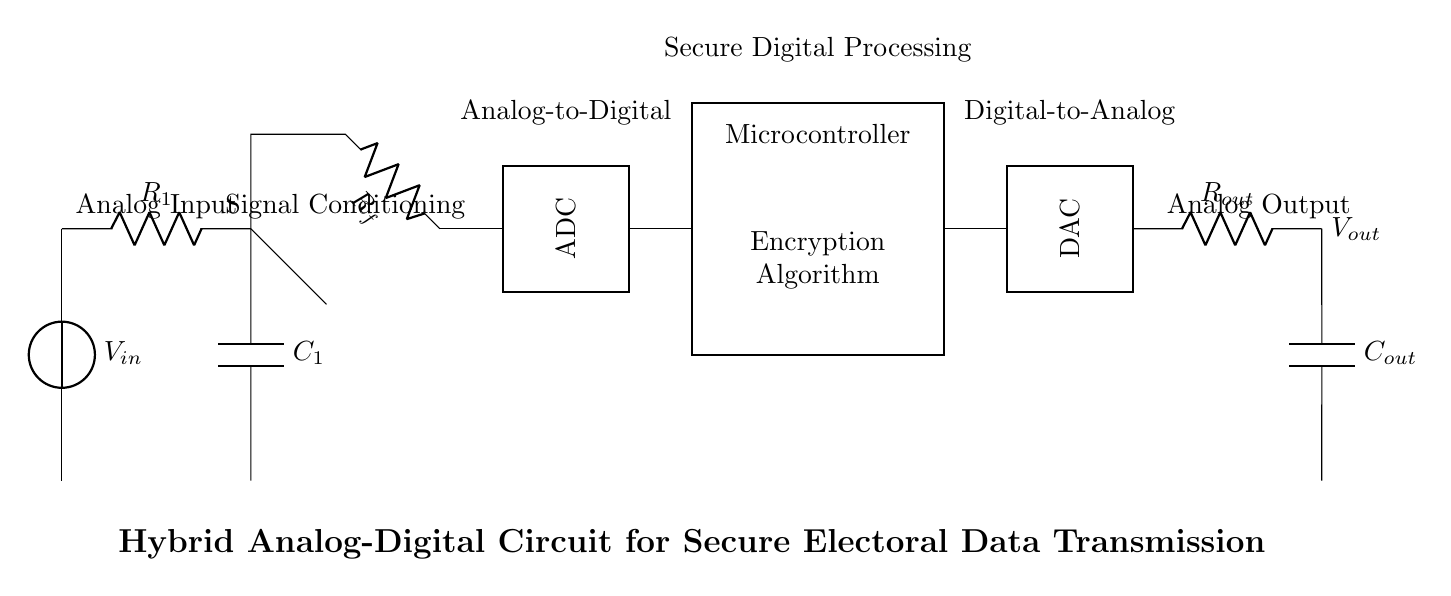what is the analog input voltage in the circuit? The analog input voltage is denoted as V_in, which represents the initial voltage supplied to the circuit.
Answer: V_in what component is responsible for signal conditioning? The resistor R1 and capacitor C1 are responsible for signal conditioning, as they modify the incoming signal before it is processed further.
Answer: R1, C1 what is the function of the operational amplifier in the circuit? The operational amplifier is used to amplify the voltage from the input before it is converted to a digital signal by the ADC.
Answer: Amplification what type of conversion occurs in the section labeled "ADC"? The ADC (Analog-to-Digital Converter) converts the analog signal into a digital signal for processing.
Answer: Analog to Digital how does this circuit ensure secure data transmission? The secure transmission is achieved through the microcontroller, which includes an encryption algorithm to protect the data.
Answer: Encryption Algorithm what is the output voltage after digital-to-analog conversion? The output voltage is indicated as V_out, which is the final voltage after passing through the DAC and conditioning stage.
Answer: V_out which component in the circuit follows the ADC block? The component that follows the ADC block is the microcontroller, which processes the digital signal.
Answer: Microcontroller 